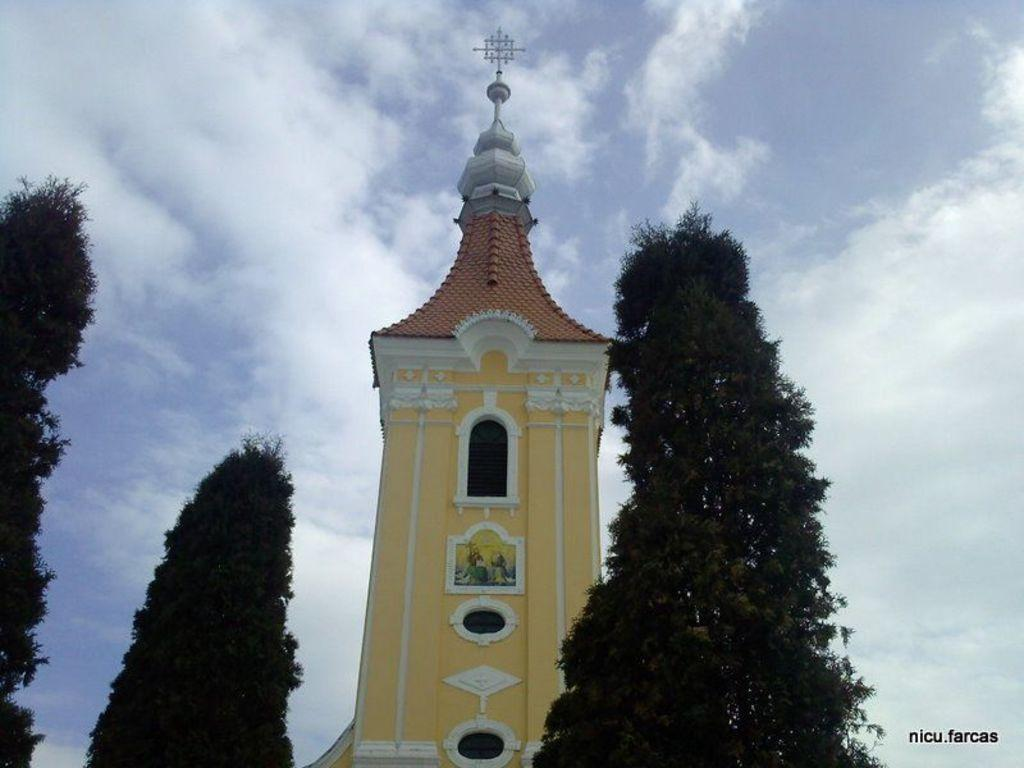What is the main structure in the center of the image? There is a tower in the center of the image. What type of vegetation is present at the bottom of the image? There are trees at the bottom of the image. What is visible at the top of the image? The sky is visible at the top of the image. What type of rule is enforced by the tower in the image? There is no indication of any rules or enforcement in the image; it simply features a tower and trees. Can you see any badges or insignias on the tower in the image? There are no badges or insignias visible on the tower in the image. 